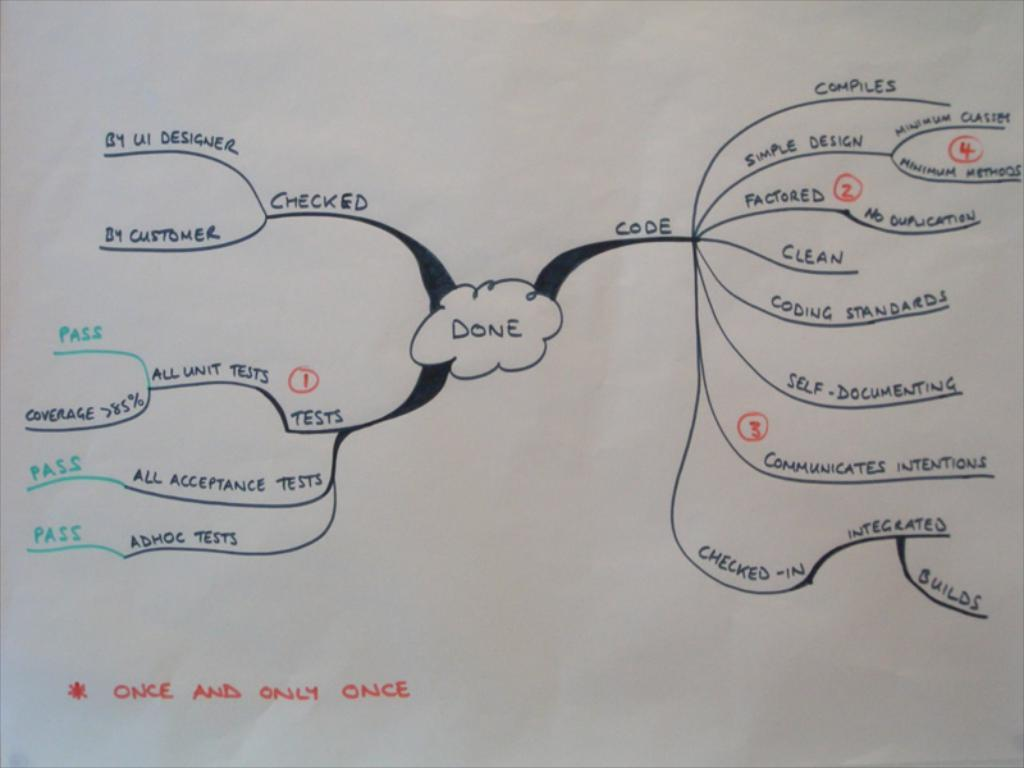<image>
Present a compact description of the photo's key features. A flow chrt list key actions that need to be done, Done is the final goal 